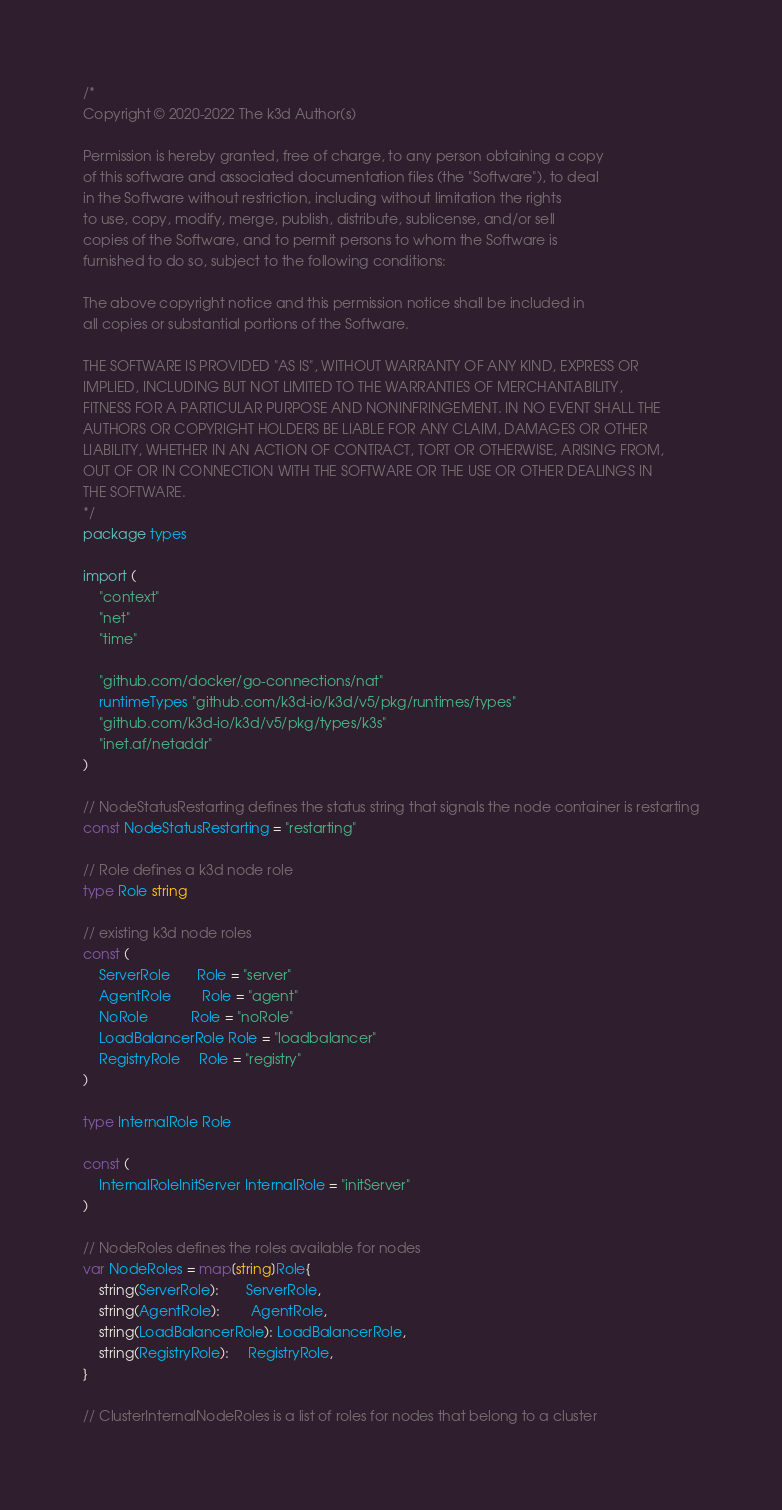<code> <loc_0><loc_0><loc_500><loc_500><_Go_>/*
Copyright © 2020-2022 The k3d Author(s)

Permission is hereby granted, free of charge, to any person obtaining a copy
of this software and associated documentation files (the "Software"), to deal
in the Software without restriction, including without limitation the rights
to use, copy, modify, merge, publish, distribute, sublicense, and/or sell
copies of the Software, and to permit persons to whom the Software is
furnished to do so, subject to the following conditions:

The above copyright notice and this permission notice shall be included in
all copies or substantial portions of the Software.

THE SOFTWARE IS PROVIDED "AS IS", WITHOUT WARRANTY OF ANY KIND, EXPRESS OR
IMPLIED, INCLUDING BUT NOT LIMITED TO THE WARRANTIES OF MERCHANTABILITY,
FITNESS FOR A PARTICULAR PURPOSE AND NONINFRINGEMENT. IN NO EVENT SHALL THE
AUTHORS OR COPYRIGHT HOLDERS BE LIABLE FOR ANY CLAIM, DAMAGES OR OTHER
LIABILITY, WHETHER IN AN ACTION OF CONTRACT, TORT OR OTHERWISE, ARISING FROM,
OUT OF OR IN CONNECTION WITH THE SOFTWARE OR THE USE OR OTHER DEALINGS IN
THE SOFTWARE.
*/
package types

import (
	"context"
	"net"
	"time"

	"github.com/docker/go-connections/nat"
	runtimeTypes "github.com/k3d-io/k3d/v5/pkg/runtimes/types"
	"github.com/k3d-io/k3d/v5/pkg/types/k3s"
	"inet.af/netaddr"
)

// NodeStatusRestarting defines the status string that signals the node container is restarting
const NodeStatusRestarting = "restarting"

// Role defines a k3d node role
type Role string

// existing k3d node roles
const (
	ServerRole       Role = "server"
	AgentRole        Role = "agent"
	NoRole           Role = "noRole"
	LoadBalancerRole Role = "loadbalancer"
	RegistryRole     Role = "registry"
)

type InternalRole Role

const (
	InternalRoleInitServer InternalRole = "initServer"
)

// NodeRoles defines the roles available for nodes
var NodeRoles = map[string]Role{
	string(ServerRole):       ServerRole,
	string(AgentRole):        AgentRole,
	string(LoadBalancerRole): LoadBalancerRole,
	string(RegistryRole):     RegistryRole,
}

// ClusterInternalNodeRoles is a list of roles for nodes that belong to a cluster</code> 